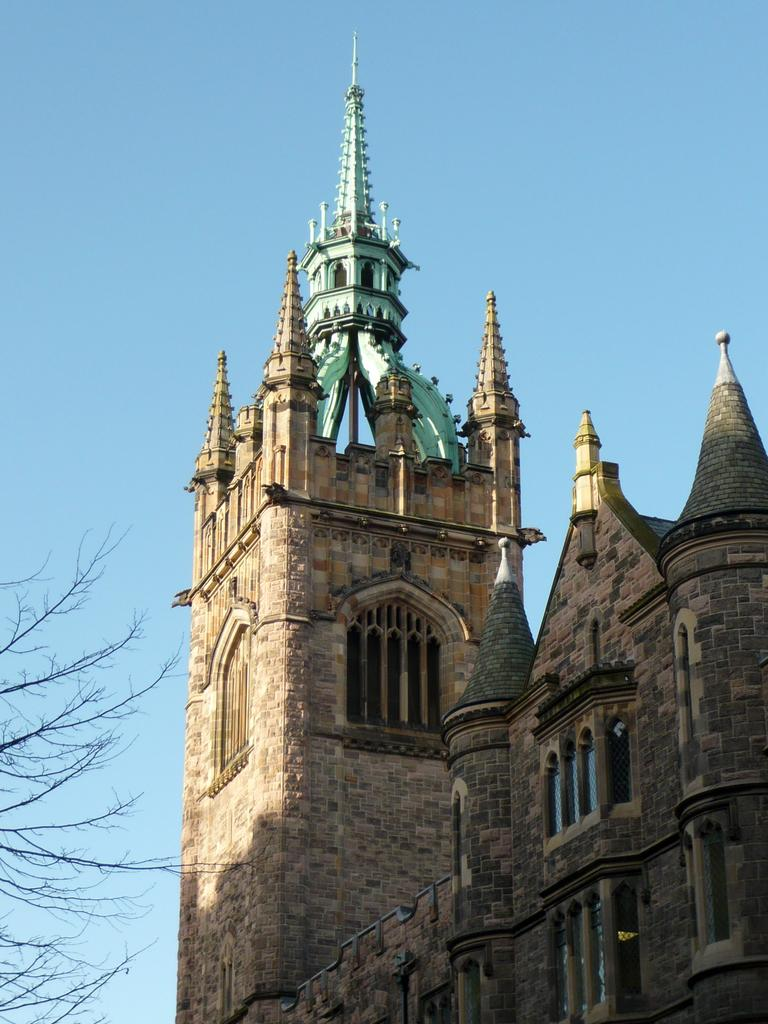What type of structure is visible in the image? There is a building in the image. What architectural features can be seen on the building? The building has pillars and arches. What material is used for the walls of the building? The building has brick walls. What can be seen on the left side of the image? There are branches on the left side of the image. What is visible in the background of the image? The sky is visible in the background of the image. How many ladybugs are crawling on the letters in the image? There are no ladybugs or letters present in the image. 